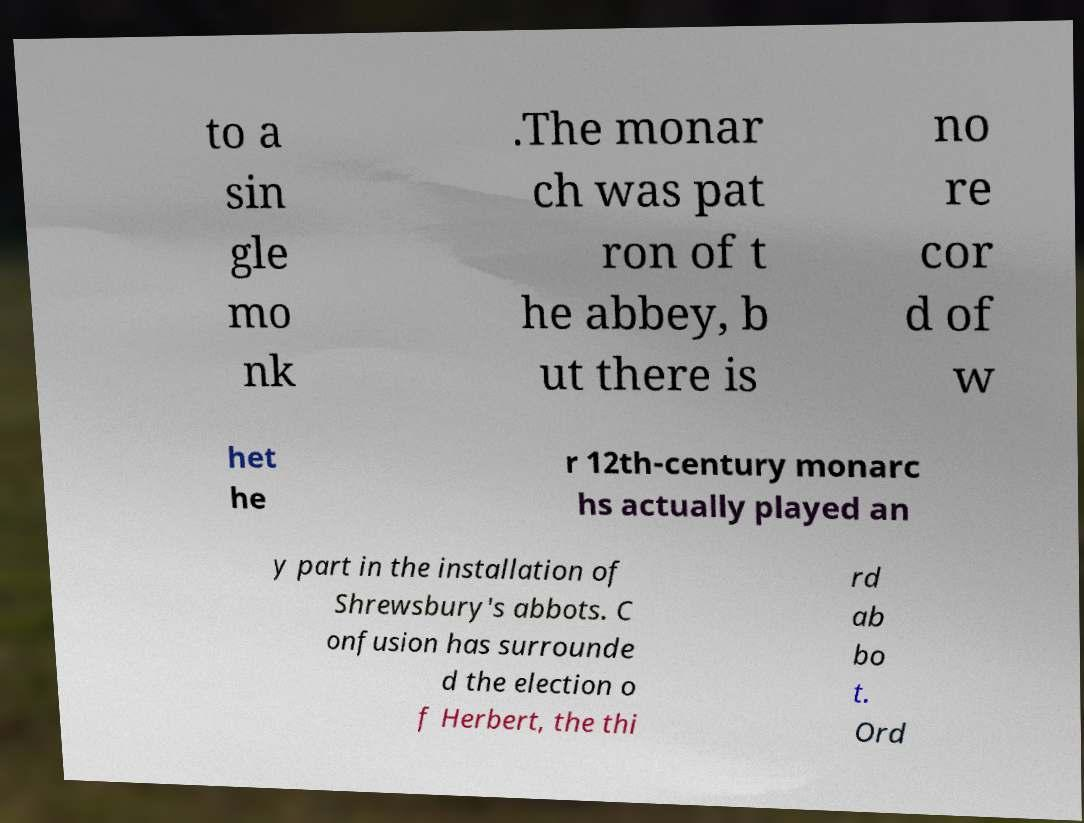Please read and relay the text visible in this image. What does it say? to a sin gle mo nk .The monar ch was pat ron of t he abbey, b ut there is no re cor d of w het he r 12th-century monarc hs actually played an y part in the installation of Shrewsbury's abbots. C onfusion has surrounde d the election o f Herbert, the thi rd ab bo t. Ord 